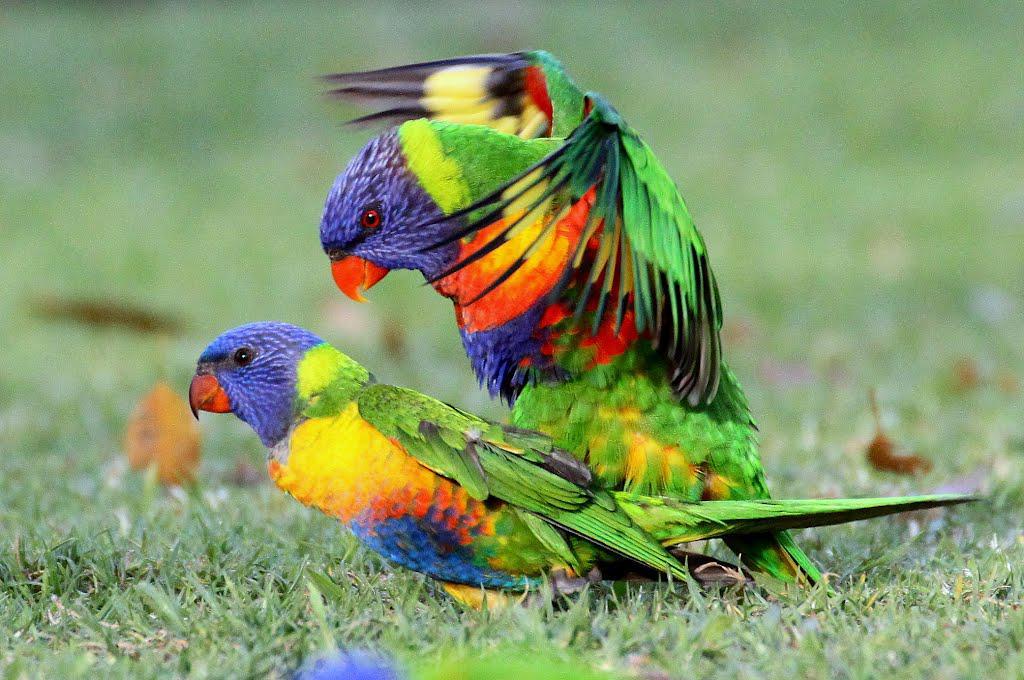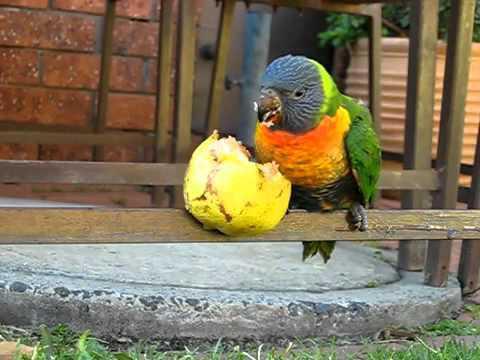The first image is the image on the left, the second image is the image on the right. Examine the images to the left and right. Is the description "There are three birds with blue head." accurate? Answer yes or no. Yes. The first image is the image on the left, the second image is the image on the right. Assess this claim about the two images: "An image shows a parrot with spread wings on top of a parrot that is on the ground.". Correct or not? Answer yes or no. Yes. 